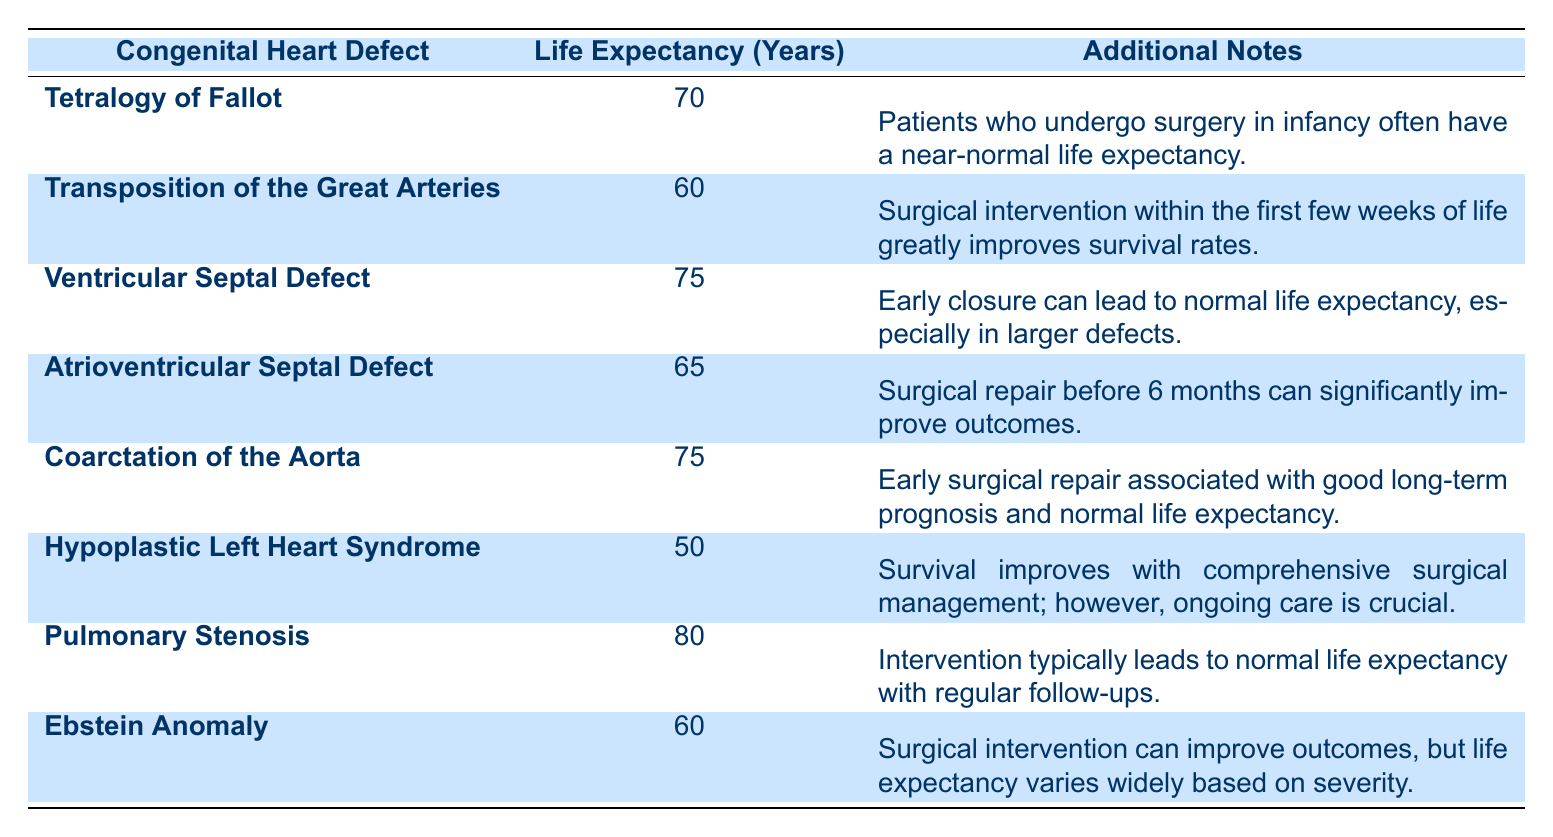What is the life expectancy of patients with Tetralogy of Fallot? The table indicates that the life expectancy of patients with Tetralogy of Fallot is listed as 70 years.
Answer: 70 years How does the life expectancy of Hypoplastic Left Heart Syndrome compare to Ventricular Septal Defect? The life expectancy of Hypoplastic Left Heart Syndrome is 50 years, while Ventricular Septal Defect has a life expectancy of 75 years. Therefore, Ventricular Septal Defect has a higher life expectancy by 25 years.
Answer: 25 years Is the average life expectancy for the defects listed greater than 65 years? To find the average, we sum the life expectancies: (70 + 60 + 75 + 65 + 75 + 50 + 80 + 60) = 595. There are 8 defects, so the average is 595/8 = 74.375, which is greater than 65.
Answer: Yes Which defects have a life expectancy of 60 years or less? The defects with a life expectancy of 60 years or less are Transposition of the Great Arteries (60 years), Hypoplastic Left Heart Syndrome (50 years), and Ebstein Anomaly (60 years).
Answer: 3 defects If a patient is diagnosed with Pulmonary Stenosis, what is their likely life expectancy? The life expectancy for patients with Pulmonary Stenosis is provided in the table as 80 years, indicating a normal life expectancy with regular follow-ups.
Answer: 80 years What is the difference in life expectancy between Coarctation of the Aorta and Atrioventricular Septal Defect? The life expectancy of Coarctation of the Aorta is 75 years, while Atrioventricular Septal Defect is 65 years. The difference is 75 - 65 = 10 years.
Answer: 10 years Does early surgical intervention improve the life expectancy of patients with Transposition of the Great Arteries? Yes, the table states that surgical intervention within the first few weeks of life greatly improves survival rates, indicating that early surgical intervention is beneficial for patients with this defect.
Answer: Yes What are the additional notes associated with Ventricular Septal Defect? The table notes that early closure of Ventricular Septal Defect can lead to normal life expectancy, especially in larger defects.
Answer: Early closure can lead to normal life expectancy, especially in larger defects 